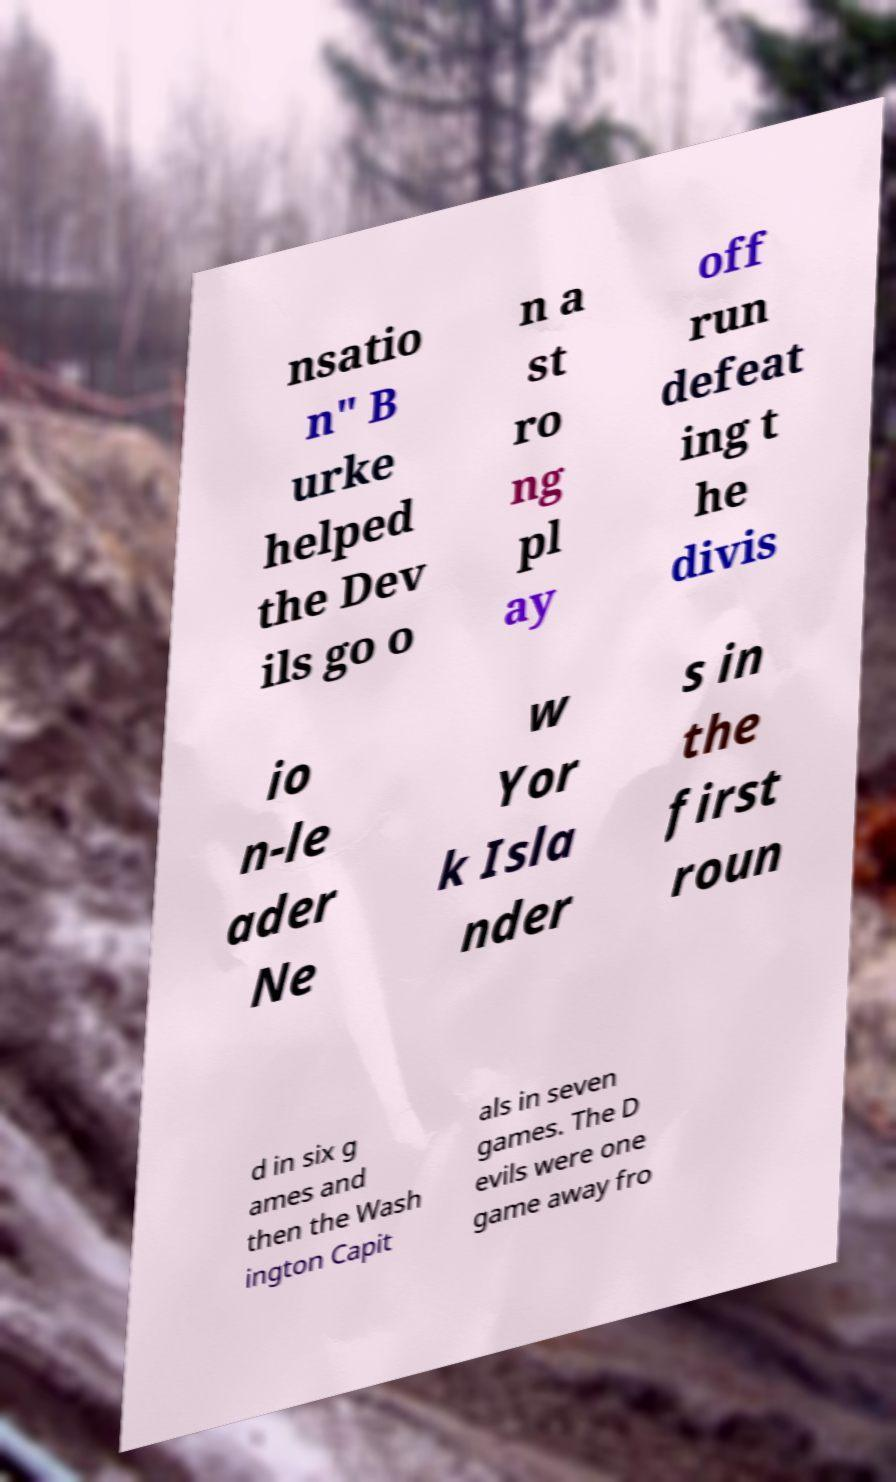Can you accurately transcribe the text from the provided image for me? nsatio n" B urke helped the Dev ils go o n a st ro ng pl ay off run defeat ing t he divis io n-le ader Ne w Yor k Isla nder s in the first roun d in six g ames and then the Wash ington Capit als in seven games. The D evils were one game away fro 